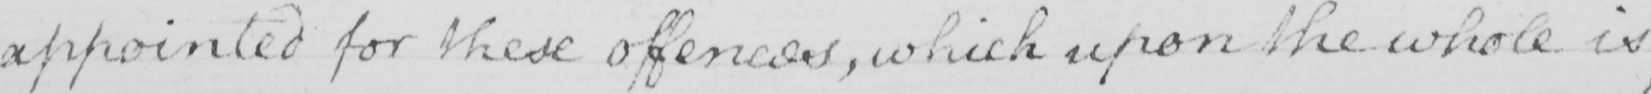Transcribe the text shown in this historical manuscript line. appointed for these offences , which upon the whole is 